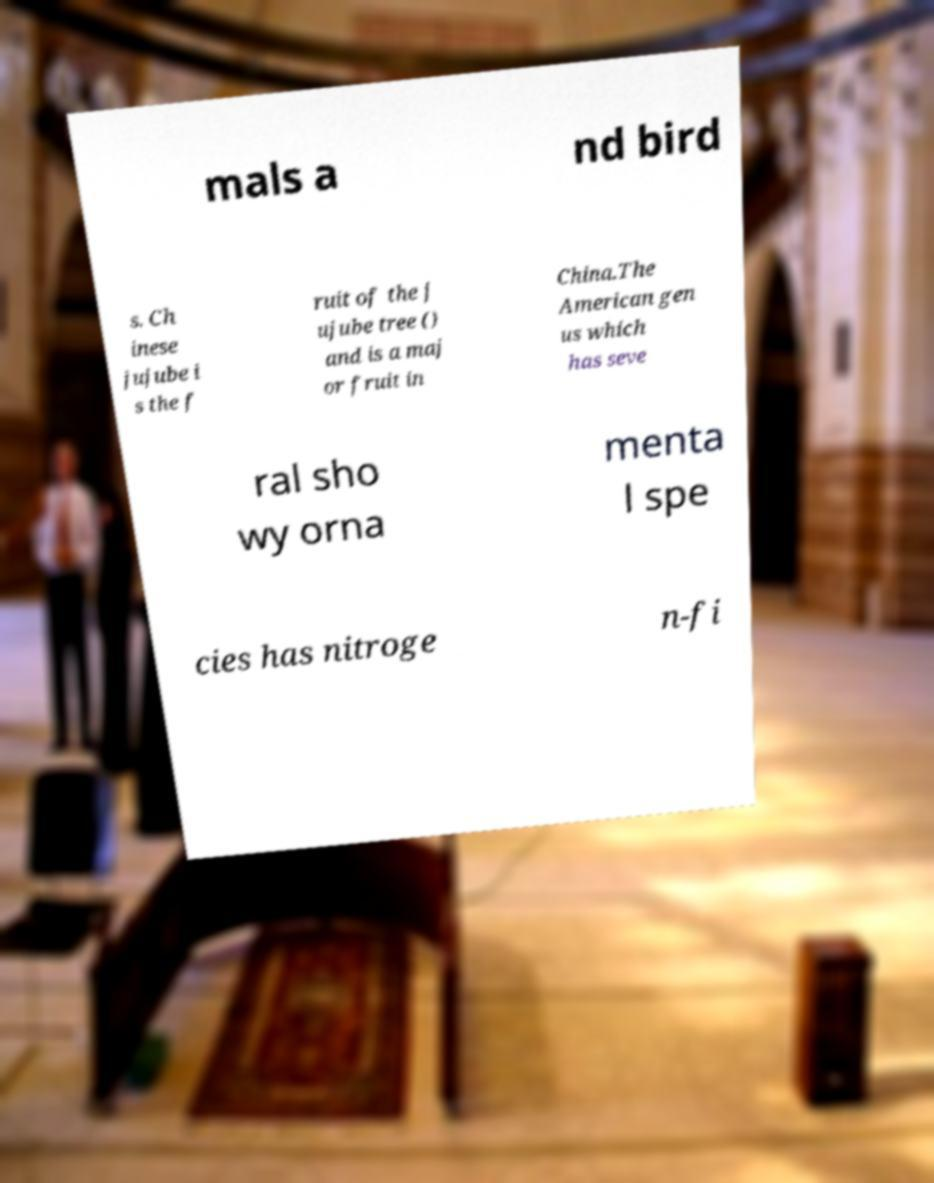What messages or text are displayed in this image? I need them in a readable, typed format. mals a nd bird s. Ch inese jujube i s the f ruit of the j ujube tree () and is a maj or fruit in China.The American gen us which has seve ral sho wy orna menta l spe cies has nitroge n-fi 